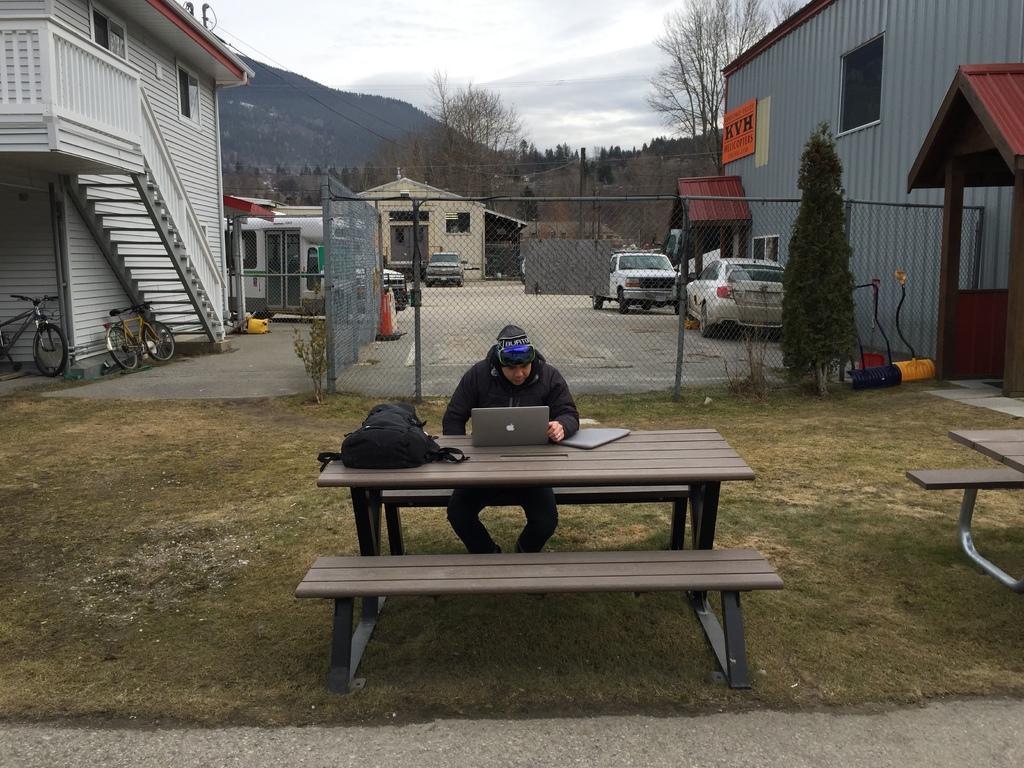Please provide a concise description of this image. This is the picture of the outside of the house. In the center we have a person. His sitting in a bench. His looking at his laptop. We can see the background there is a trees,sky,mountain and vehicles. 